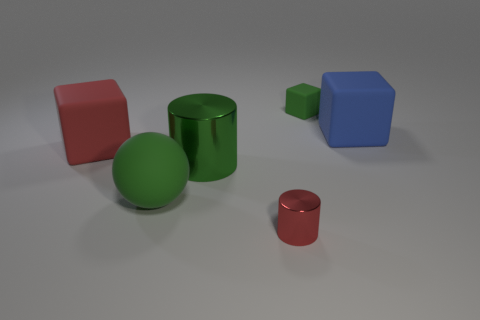Do the green matte sphere and the metal cylinder left of the tiny red metal cylinder have the same size? Upon closer inspection, the green matte sphere and the taller metal cylinder to the left of the small red cylinder do indeed appear to have the same height, which suggests they have the same size in terms of their dimension in that direction. However, without knowing the exact scale or having a reference, we cannot decisively determine if their volume is identical. 